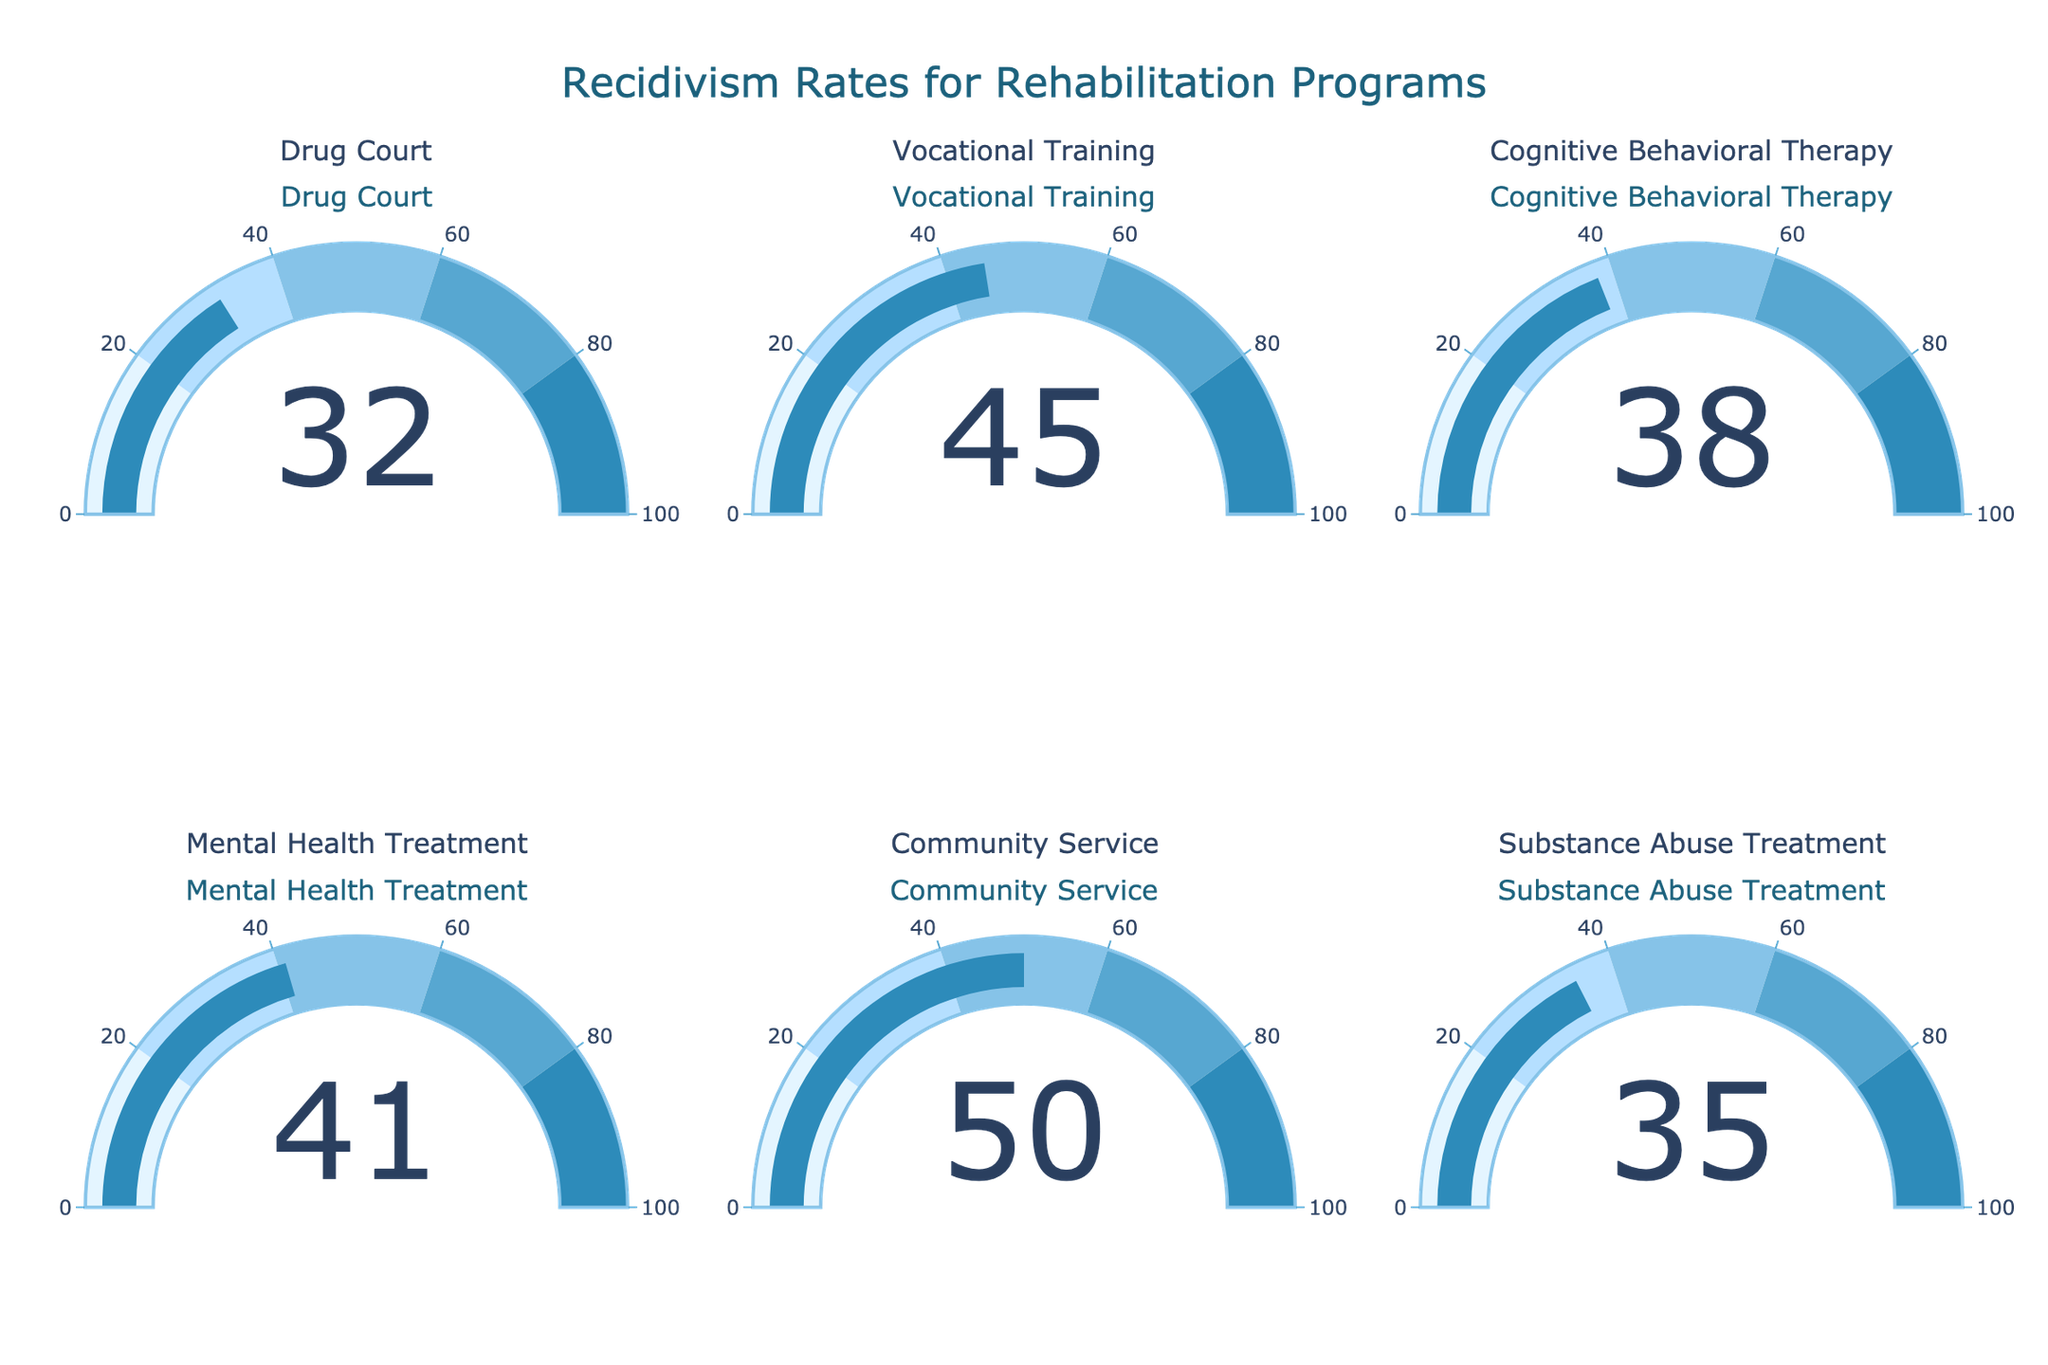What's the title of the figure? The title is often displayed prominently at the top of the figure for users to understand the overall focus at a glance. Here, it's specified by the chart code.
Answer: Recidivism Rates for Rehabilitation Programs How many rehabilitation programs are displayed in the figure? Each program is represented by a gauge chart, the number of which can be counted visually.
Answer: Six Which rehabilitation program has the highest recidivism rate? Look at the values displayed on each gauge and determine which one is the highest.
Answer: Community Service What's the recidivism rate for the Substance Abuse Treatment program? Refer to the section of the chart labeled "Substance Abuse Treatment" and note the number displayed on the gauge.
Answer: 35 Which program has a lower recidivism rate: Mental Health Treatment or Vocational Training? Compare the values displayed on the gauges for these two programs.
Answer: Mental Health Treatment What's the difference in recidivism rates between Cognitive Behavioral Therapy and Mental Health Treatment? Subtract the value for Mental Health Treatment from the value for Cognitive Behavioral Therapy.
Answer: 38 - 41 = -3 What is the average recidivism rate across all displayed rehabilitation programs? Add all the recidivism rates together and divide by the number of programs.
Answer: (32 + 45 + 38 + 41 + 50 + 35) / 6 = 40.17 Are any programs in the figure displayed with a recidivism rate below 30%? Check each gauge for any values less than 30.
Answer: No Which program shows a recidivism rate closest to the average rate of all programs? Calculate the average recidivism rate and find the program with a rate closest to this value. The average is 40.17, compare this to each program's rate.
Answer: Cognitive Behavioral Therapy 